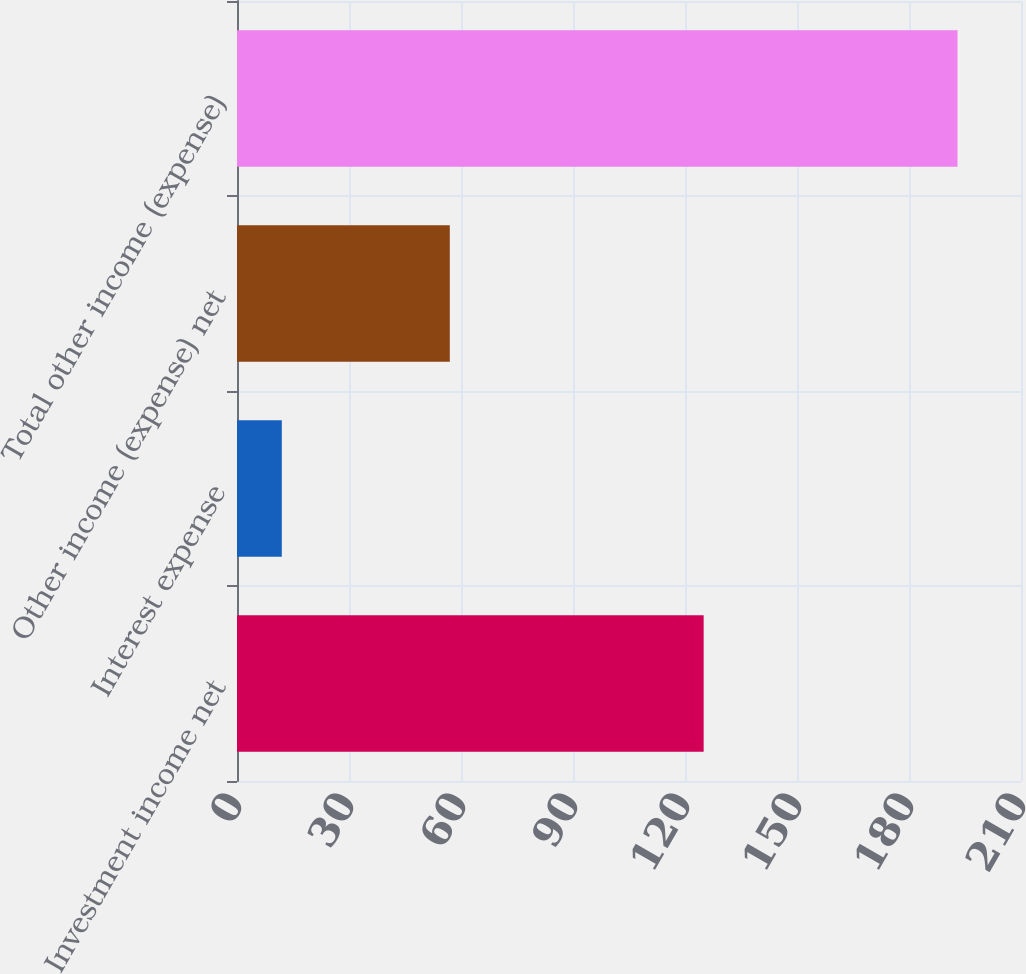Convert chart to OTSL. <chart><loc_0><loc_0><loc_500><loc_500><bar_chart><fcel>Investment income net<fcel>Interest expense<fcel>Other income (expense) net<fcel>Total other income (expense)<nl><fcel>125<fcel>12<fcel>57<fcel>193<nl></chart> 